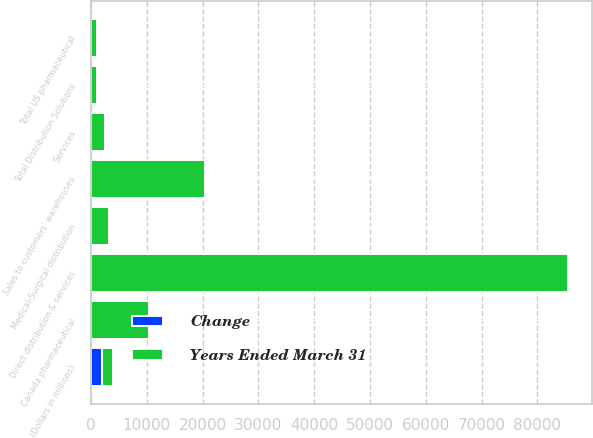Convert chart. <chart><loc_0><loc_0><loc_500><loc_500><stacked_bar_chart><ecel><fcel>(Dollars in millions)<fcel>Direct distribution & services<fcel>Sales to customers' warehouses<fcel>Total US pharmaceutical<fcel>Canada pharmaceutical<fcel>Medical-Surgical distribution<fcel>Total Distribution Solutions<fcel>Services<nl><fcel>Years Ended March 31<fcel>2012<fcel>85523<fcel>20453<fcel>1011<fcel>10303<fcel>3145<fcel>1011<fcel>2594<nl><fcel>Change<fcel>2012<fcel>10<fcel>10<fcel>10<fcel>5<fcel>8<fcel>10<fcel>4<nl></chart> 